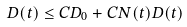Convert formula to latex. <formula><loc_0><loc_0><loc_500><loc_500>D ( t ) \leq C D _ { 0 } + C N ( t ) D ( t )</formula> 